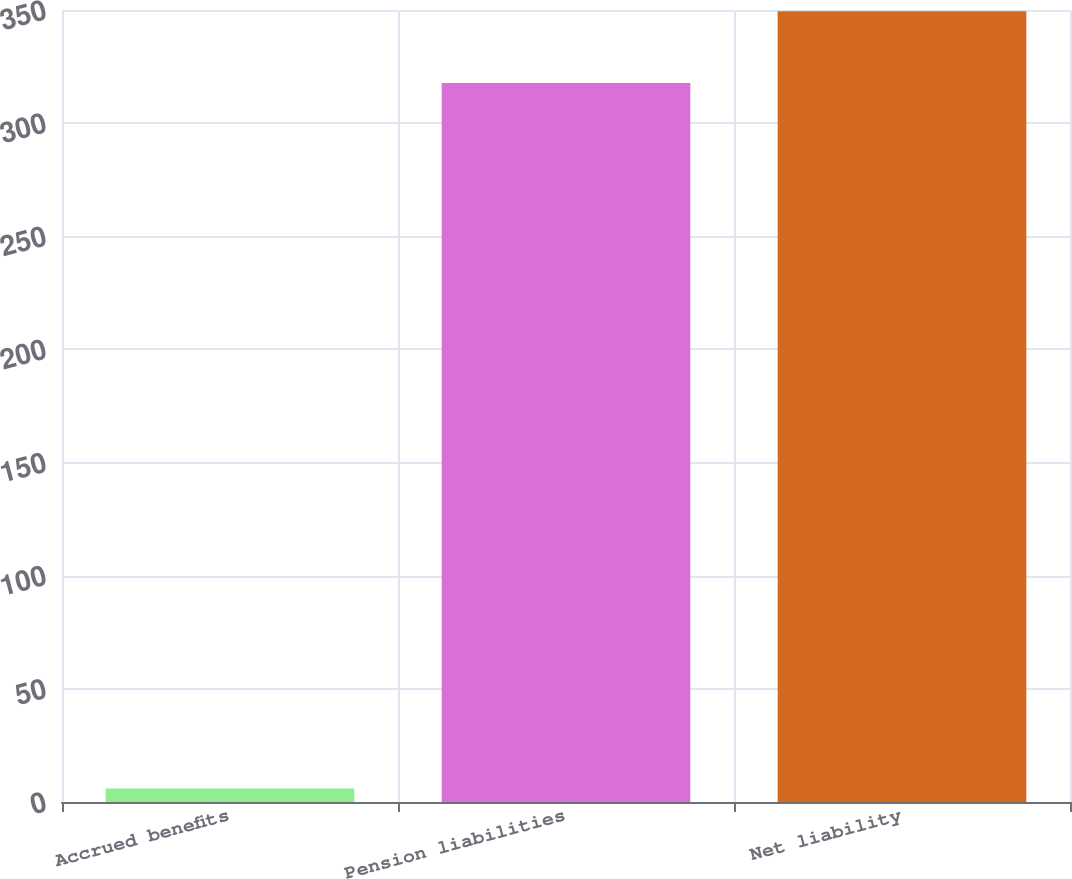Convert chart to OTSL. <chart><loc_0><loc_0><loc_500><loc_500><bar_chart><fcel>Accrued benefits<fcel>Pension liabilities<fcel>Net liability<nl><fcel>6<fcel>317.7<fcel>349.46<nl></chart> 